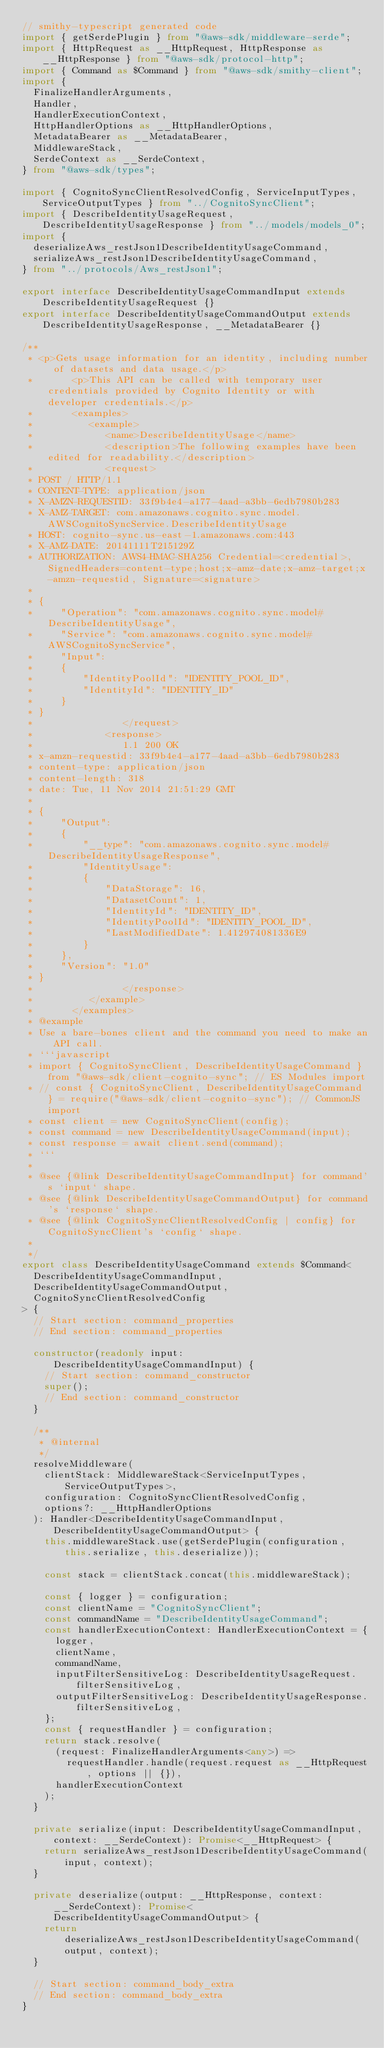Convert code to text. <code><loc_0><loc_0><loc_500><loc_500><_TypeScript_>// smithy-typescript generated code
import { getSerdePlugin } from "@aws-sdk/middleware-serde";
import { HttpRequest as __HttpRequest, HttpResponse as __HttpResponse } from "@aws-sdk/protocol-http";
import { Command as $Command } from "@aws-sdk/smithy-client";
import {
  FinalizeHandlerArguments,
  Handler,
  HandlerExecutionContext,
  HttpHandlerOptions as __HttpHandlerOptions,
  MetadataBearer as __MetadataBearer,
  MiddlewareStack,
  SerdeContext as __SerdeContext,
} from "@aws-sdk/types";

import { CognitoSyncClientResolvedConfig, ServiceInputTypes, ServiceOutputTypes } from "../CognitoSyncClient";
import { DescribeIdentityUsageRequest, DescribeIdentityUsageResponse } from "../models/models_0";
import {
  deserializeAws_restJson1DescribeIdentityUsageCommand,
  serializeAws_restJson1DescribeIdentityUsageCommand,
} from "../protocols/Aws_restJson1";

export interface DescribeIdentityUsageCommandInput extends DescribeIdentityUsageRequest {}
export interface DescribeIdentityUsageCommandOutput extends DescribeIdentityUsageResponse, __MetadataBearer {}

/**
 * <p>Gets usage information for an identity, including number of datasets and data usage.</p>
 *       <p>This API can be called with temporary user credentials provided by Cognito Identity or with developer credentials.</p>
 *       <examples>
 *          <example>
 *             <name>DescribeIdentityUsage</name>
 *             <description>The following examples have been edited for readability.</description>
 *             <request>
 * POST / HTTP/1.1
 * CONTENT-TYPE: application/json
 * X-AMZN-REQUESTID: 33f9b4e4-a177-4aad-a3bb-6edb7980b283
 * X-AMZ-TARGET: com.amazonaws.cognito.sync.model.AWSCognitoSyncService.DescribeIdentityUsage
 * HOST: cognito-sync.us-east-1.amazonaws.com:443
 * X-AMZ-DATE: 20141111T215129Z
 * AUTHORIZATION: AWS4-HMAC-SHA256 Credential=<credential>, SignedHeaders=content-type;host;x-amz-date;x-amz-target;x-amzn-requestid, Signature=<signature>
 *
 * {
 *     "Operation": "com.amazonaws.cognito.sync.model#DescribeIdentityUsage",
 *     "Service": "com.amazonaws.cognito.sync.model#AWSCognitoSyncService",
 *     "Input":
 *     {
 *         "IdentityPoolId": "IDENTITY_POOL_ID",
 *         "IdentityId": "IDENTITY_ID"
 *     }
 * }
 *                </request>
 *             <response>
 *                1.1 200 OK
 * x-amzn-requestid: 33f9b4e4-a177-4aad-a3bb-6edb7980b283
 * content-type: application/json
 * content-length: 318
 * date: Tue, 11 Nov 2014 21:51:29 GMT
 *
 * {
 *     "Output":
 *     {
 *         "__type": "com.amazonaws.cognito.sync.model#DescribeIdentityUsageResponse",
 *         "IdentityUsage":
 *         {
 *             "DataStorage": 16,
 *             "DatasetCount": 1,
 *             "IdentityId": "IDENTITY_ID",
 *             "IdentityPoolId": "IDENTITY_POOL_ID",
 *             "LastModifiedDate": 1.412974081336E9
 *         }
 *     },
 *     "Version": "1.0"
 * }
 *                </response>
 *          </example>
 *       </examples>
 * @example
 * Use a bare-bones client and the command you need to make an API call.
 * ```javascript
 * import { CognitoSyncClient, DescribeIdentityUsageCommand } from "@aws-sdk/client-cognito-sync"; // ES Modules import
 * // const { CognitoSyncClient, DescribeIdentityUsageCommand } = require("@aws-sdk/client-cognito-sync"); // CommonJS import
 * const client = new CognitoSyncClient(config);
 * const command = new DescribeIdentityUsageCommand(input);
 * const response = await client.send(command);
 * ```
 *
 * @see {@link DescribeIdentityUsageCommandInput} for command's `input` shape.
 * @see {@link DescribeIdentityUsageCommandOutput} for command's `response` shape.
 * @see {@link CognitoSyncClientResolvedConfig | config} for CognitoSyncClient's `config` shape.
 *
 */
export class DescribeIdentityUsageCommand extends $Command<
  DescribeIdentityUsageCommandInput,
  DescribeIdentityUsageCommandOutput,
  CognitoSyncClientResolvedConfig
> {
  // Start section: command_properties
  // End section: command_properties

  constructor(readonly input: DescribeIdentityUsageCommandInput) {
    // Start section: command_constructor
    super();
    // End section: command_constructor
  }

  /**
   * @internal
   */
  resolveMiddleware(
    clientStack: MiddlewareStack<ServiceInputTypes, ServiceOutputTypes>,
    configuration: CognitoSyncClientResolvedConfig,
    options?: __HttpHandlerOptions
  ): Handler<DescribeIdentityUsageCommandInput, DescribeIdentityUsageCommandOutput> {
    this.middlewareStack.use(getSerdePlugin(configuration, this.serialize, this.deserialize));

    const stack = clientStack.concat(this.middlewareStack);

    const { logger } = configuration;
    const clientName = "CognitoSyncClient";
    const commandName = "DescribeIdentityUsageCommand";
    const handlerExecutionContext: HandlerExecutionContext = {
      logger,
      clientName,
      commandName,
      inputFilterSensitiveLog: DescribeIdentityUsageRequest.filterSensitiveLog,
      outputFilterSensitiveLog: DescribeIdentityUsageResponse.filterSensitiveLog,
    };
    const { requestHandler } = configuration;
    return stack.resolve(
      (request: FinalizeHandlerArguments<any>) =>
        requestHandler.handle(request.request as __HttpRequest, options || {}),
      handlerExecutionContext
    );
  }

  private serialize(input: DescribeIdentityUsageCommandInput, context: __SerdeContext): Promise<__HttpRequest> {
    return serializeAws_restJson1DescribeIdentityUsageCommand(input, context);
  }

  private deserialize(output: __HttpResponse, context: __SerdeContext): Promise<DescribeIdentityUsageCommandOutput> {
    return deserializeAws_restJson1DescribeIdentityUsageCommand(output, context);
  }

  // Start section: command_body_extra
  // End section: command_body_extra
}
</code> 